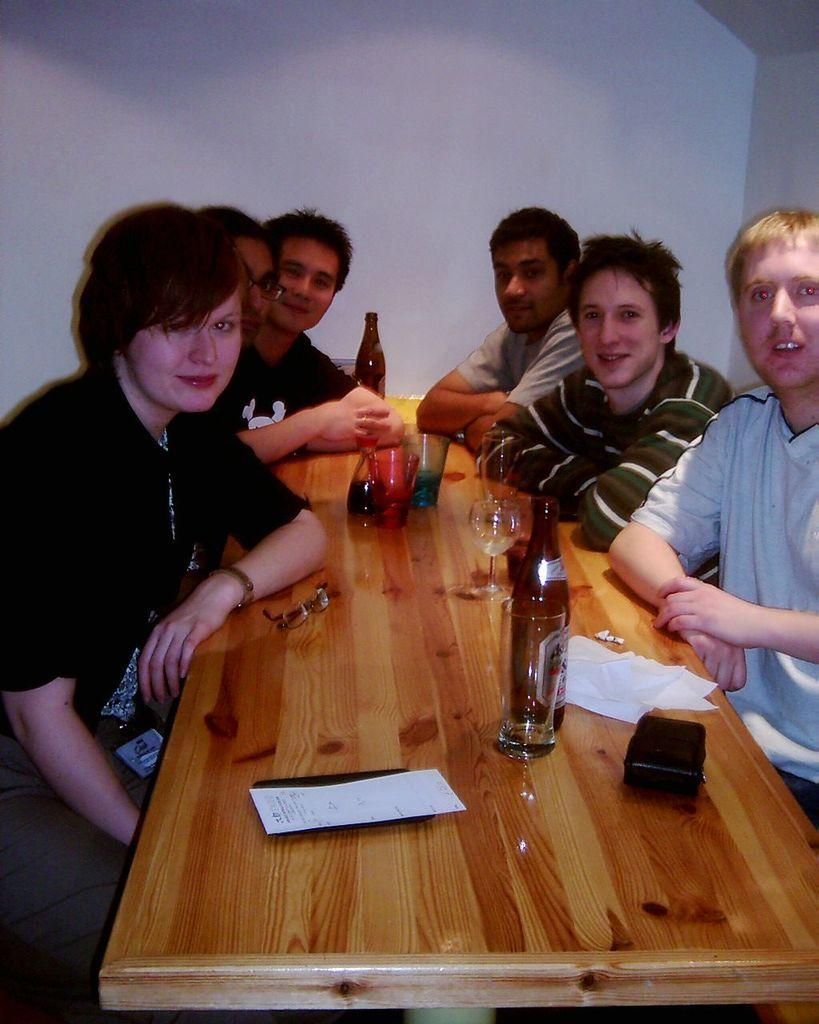What are the people in the image doing? The people in the image are sitting around a table. What can be seen on the table in the image? There are alcohol bottles and glasses on the table. What type of grass is growing on the table in the image? There is no grass present on the table in the image. What is the sound of the people in the image making? The provided facts do not mention any sounds or laughter, so it cannot be determined from the image. 